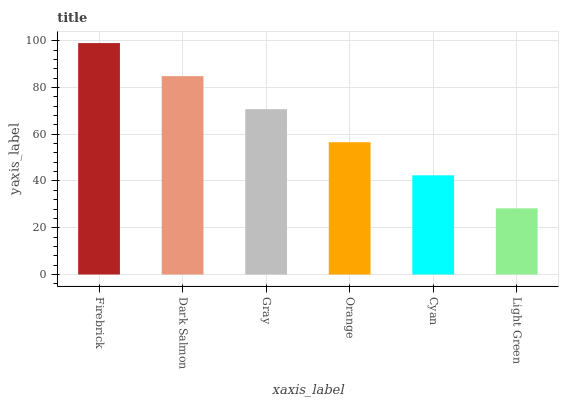Is Light Green the minimum?
Answer yes or no. Yes. Is Firebrick the maximum?
Answer yes or no. Yes. Is Dark Salmon the minimum?
Answer yes or no. No. Is Dark Salmon the maximum?
Answer yes or no. No. Is Firebrick greater than Dark Salmon?
Answer yes or no. Yes. Is Dark Salmon less than Firebrick?
Answer yes or no. Yes. Is Dark Salmon greater than Firebrick?
Answer yes or no. No. Is Firebrick less than Dark Salmon?
Answer yes or no. No. Is Gray the high median?
Answer yes or no. Yes. Is Orange the low median?
Answer yes or no. Yes. Is Light Green the high median?
Answer yes or no. No. Is Firebrick the low median?
Answer yes or no. No. 